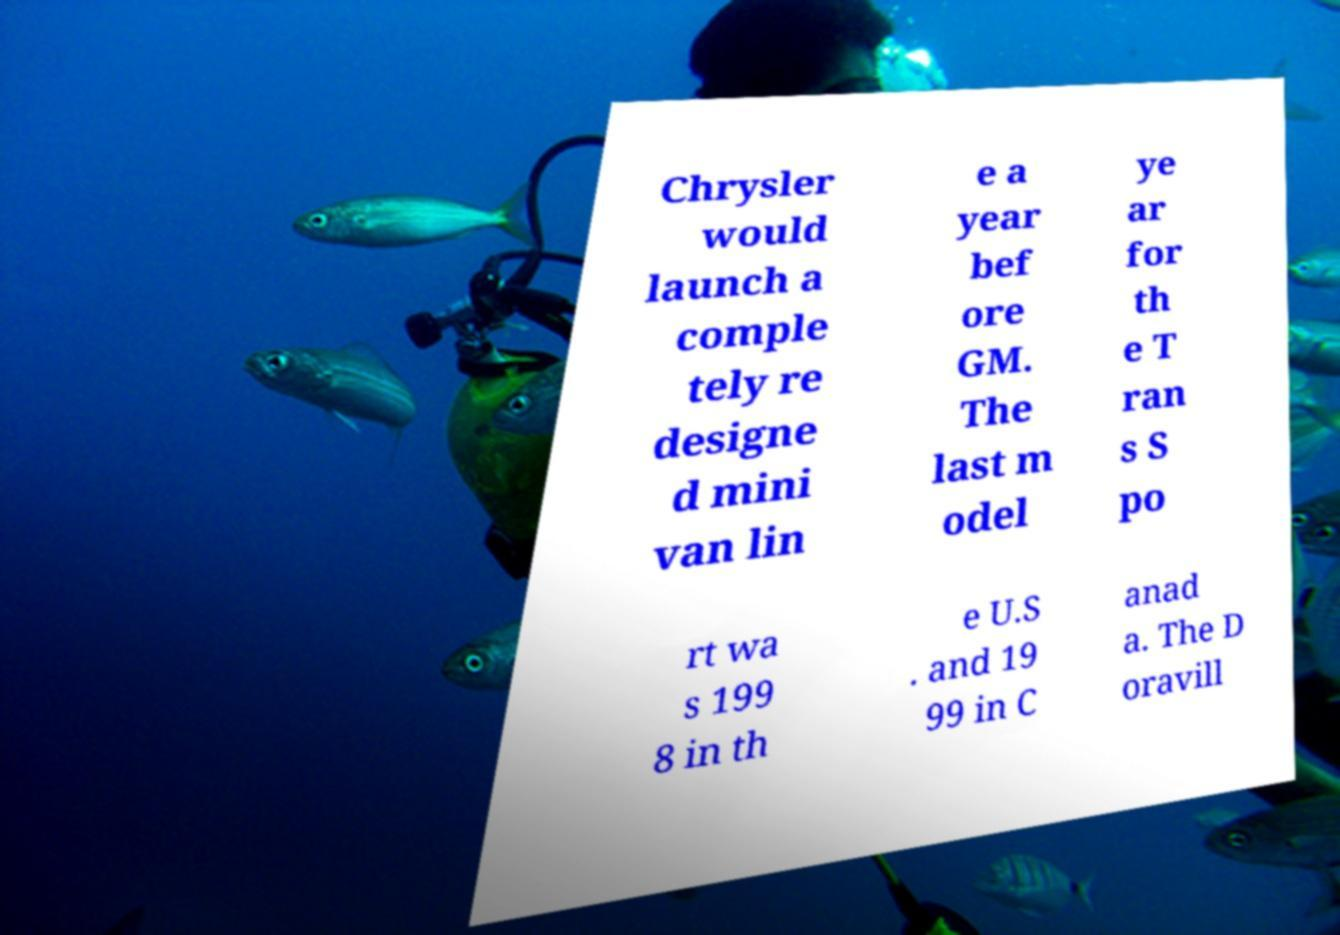What messages or text are displayed in this image? I need them in a readable, typed format. Chrysler would launch a comple tely re designe d mini van lin e a year bef ore GM. The last m odel ye ar for th e T ran s S po rt wa s 199 8 in th e U.S . and 19 99 in C anad a. The D oravill 